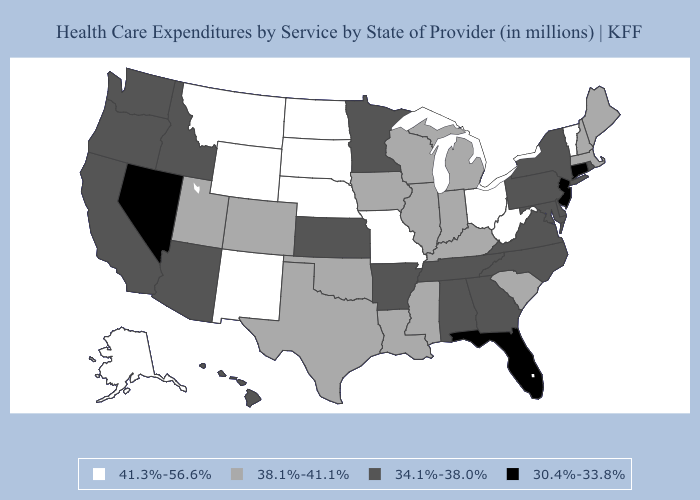Which states hav the highest value in the Northeast?
Answer briefly. Vermont. Name the states that have a value in the range 38.1%-41.1%?
Short answer required. Colorado, Illinois, Indiana, Iowa, Kentucky, Louisiana, Maine, Massachusetts, Michigan, Mississippi, New Hampshire, Oklahoma, South Carolina, Texas, Utah, Wisconsin. Does Alaska have a higher value than Nebraska?
Write a very short answer. No. Does West Virginia have a lower value than Michigan?
Write a very short answer. No. Among the states that border Delaware , does Pennsylvania have the highest value?
Give a very brief answer. Yes. Name the states that have a value in the range 38.1%-41.1%?
Quick response, please. Colorado, Illinois, Indiana, Iowa, Kentucky, Louisiana, Maine, Massachusetts, Michigan, Mississippi, New Hampshire, Oklahoma, South Carolina, Texas, Utah, Wisconsin. Among the states that border West Virginia , which have the highest value?
Write a very short answer. Ohio. Does the map have missing data?
Quick response, please. No. Name the states that have a value in the range 34.1%-38.0%?
Be succinct. Alabama, Arizona, Arkansas, California, Delaware, Georgia, Hawaii, Idaho, Kansas, Maryland, Minnesota, New York, North Carolina, Oregon, Pennsylvania, Rhode Island, Tennessee, Virginia, Washington. Does Wyoming have a higher value than North Dakota?
Answer briefly. No. Which states hav the highest value in the West?
Write a very short answer. Alaska, Montana, New Mexico, Wyoming. Name the states that have a value in the range 34.1%-38.0%?
Concise answer only. Alabama, Arizona, Arkansas, California, Delaware, Georgia, Hawaii, Idaho, Kansas, Maryland, Minnesota, New York, North Carolina, Oregon, Pennsylvania, Rhode Island, Tennessee, Virginia, Washington. Does New Jersey have the lowest value in the USA?
Quick response, please. Yes. Does New Jersey have a lower value than Indiana?
Short answer required. Yes. What is the lowest value in the West?
Be succinct. 30.4%-33.8%. 